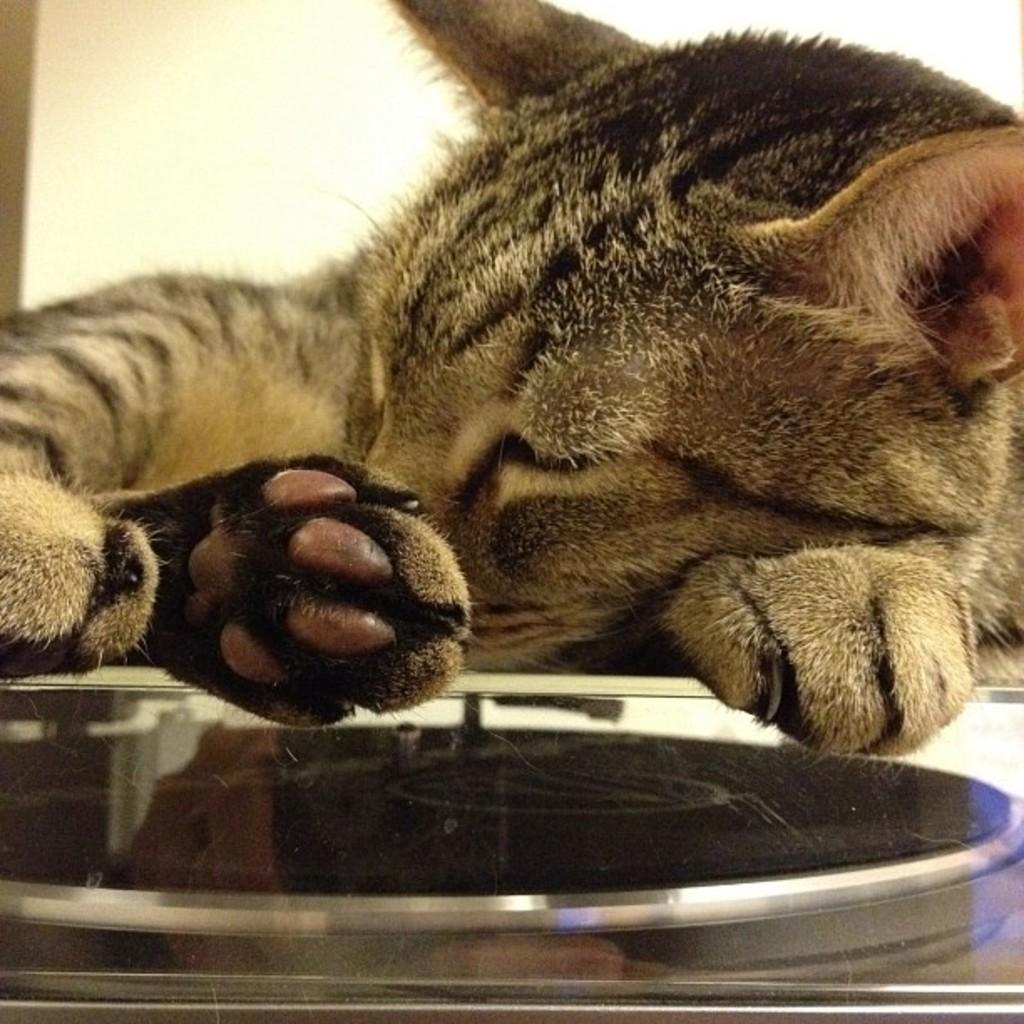In one or two sentences, can you explain what this image depicts? In the image there is a cat lying. In front of the cat there is an object which looks like a glass. 